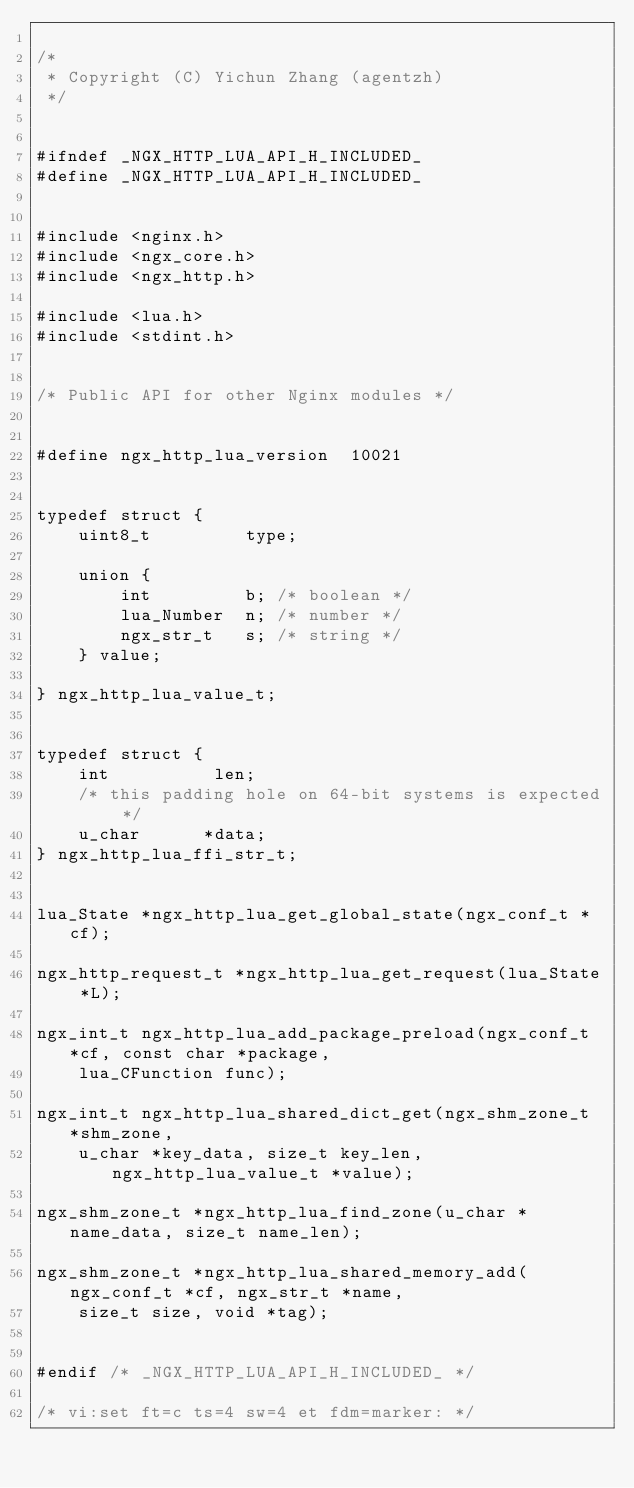<code> <loc_0><loc_0><loc_500><loc_500><_C_>
/*
 * Copyright (C) Yichun Zhang (agentzh)
 */


#ifndef _NGX_HTTP_LUA_API_H_INCLUDED_
#define _NGX_HTTP_LUA_API_H_INCLUDED_


#include <nginx.h>
#include <ngx_core.h>
#include <ngx_http.h>

#include <lua.h>
#include <stdint.h>


/* Public API for other Nginx modules */


#define ngx_http_lua_version  10021


typedef struct {
    uint8_t         type;

    union {
        int         b; /* boolean */
        lua_Number  n; /* number */
        ngx_str_t   s; /* string */
    } value;

} ngx_http_lua_value_t;


typedef struct {
    int          len;
    /* this padding hole on 64-bit systems is expected */
    u_char      *data;
} ngx_http_lua_ffi_str_t;


lua_State *ngx_http_lua_get_global_state(ngx_conf_t *cf);

ngx_http_request_t *ngx_http_lua_get_request(lua_State *L);

ngx_int_t ngx_http_lua_add_package_preload(ngx_conf_t *cf, const char *package,
    lua_CFunction func);

ngx_int_t ngx_http_lua_shared_dict_get(ngx_shm_zone_t *shm_zone,
    u_char *key_data, size_t key_len, ngx_http_lua_value_t *value);

ngx_shm_zone_t *ngx_http_lua_find_zone(u_char *name_data, size_t name_len);

ngx_shm_zone_t *ngx_http_lua_shared_memory_add(ngx_conf_t *cf, ngx_str_t *name,
    size_t size, void *tag);


#endif /* _NGX_HTTP_LUA_API_H_INCLUDED_ */

/* vi:set ft=c ts=4 sw=4 et fdm=marker: */
</code> 